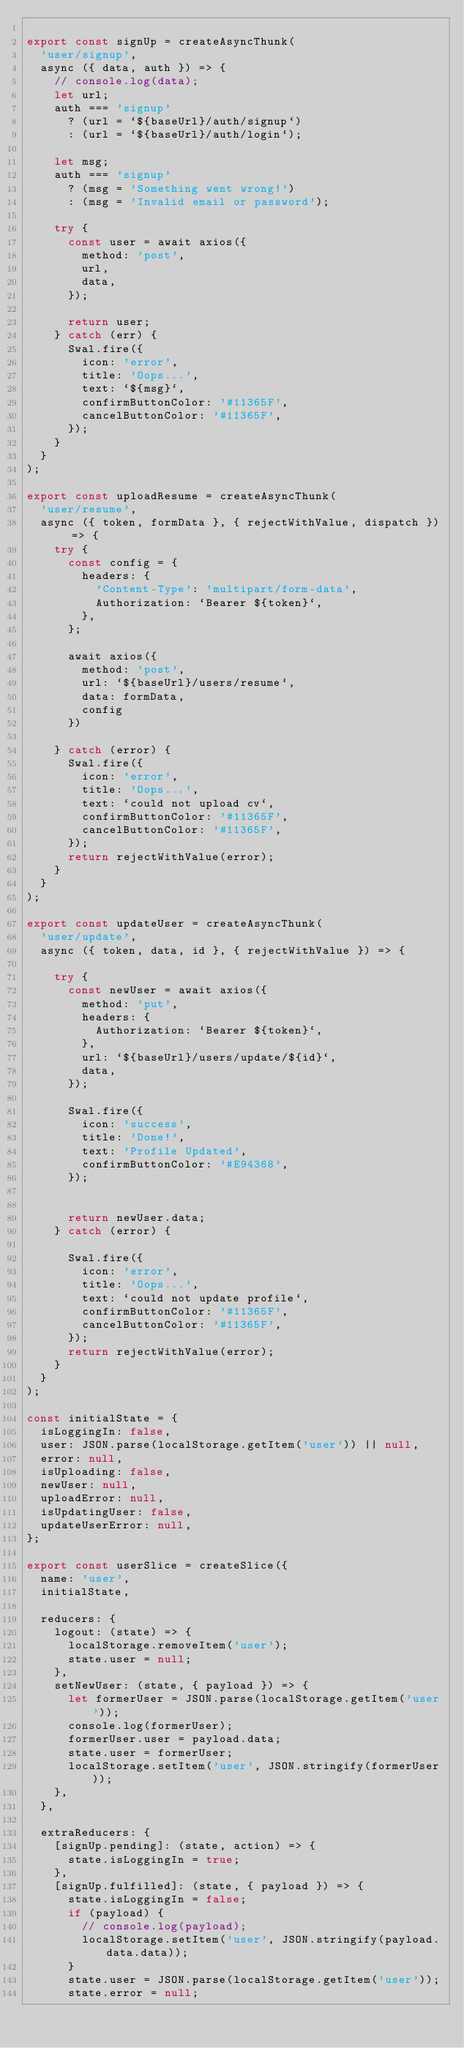<code> <loc_0><loc_0><loc_500><loc_500><_JavaScript_>
export const signUp = createAsyncThunk(
  'user/signup',
  async ({ data, auth }) => {
    // console.log(data);
    let url;
    auth === 'signup'
      ? (url = `${baseUrl}/auth/signup`)
      : (url = `${baseUrl}/auth/login`);

    let msg;
    auth === 'signup'
      ? (msg = 'Something went wrong!')
      : (msg = 'Invalid email or password');

    try {
      const user = await axios({
        method: 'post',
        url,
        data,
      });

      return user;
    } catch (err) {
      Swal.fire({
        icon: 'error',
        title: 'Oops...',
        text: `${msg}`,
        confirmButtonColor: '#11365F',
        cancelButtonColor: '#11365F',
      });
    }
  }
);

export const uploadResume = createAsyncThunk(
  'user/resume',
  async ({ token, formData }, { rejectWithValue, dispatch }) => {
    try {
      const config = {
        headers: {
          'Content-Type': 'multipart/form-data',
          Authorization: `Bearer ${token}`,
        },
      };

      await axios({
        method: 'post',
        url: `${baseUrl}/users/resume`,
        data: formData,
        config
      })

    } catch (error) {
      Swal.fire({
        icon: 'error',
        title: 'Oops...',
        text: `could not upload cv`,
        confirmButtonColor: '#11365F',
        cancelButtonColor: '#11365F',
      });
      return rejectWithValue(error);
    }
  }
);

export const updateUser = createAsyncThunk(
  'user/update',
  async ({ token, data, id }, { rejectWithValue }) => {

    try {
      const newUser = await axios({
        method: 'put',
        headers: {
          Authorization: `Bearer ${token}`,
        },
        url: `${baseUrl}/users/update/${id}`,
        data,
      });

      Swal.fire({
        icon: 'success',
        title: 'Done!',
        text: 'Profile Updated',
        confirmButtonColor: '#E94368',
      });


      return newUser.data;
    } catch (error) {

      Swal.fire({
        icon: 'error',
        title: 'Oops...',
        text: `could not update profile`,
        confirmButtonColor: '#11365F',
        cancelButtonColor: '#11365F',
      });
      return rejectWithValue(error);
    }
  }
);

const initialState = {
  isLoggingIn: false,
  user: JSON.parse(localStorage.getItem('user')) || null,
  error: null,
  isUploading: false,
  newUser: null,
  uploadError: null,
  isUpdatingUser: false,
  updateUserError: null,
};

export const userSlice = createSlice({
  name: 'user',
  initialState,

  reducers: {
    logout: (state) => {
      localStorage.removeItem('user');
      state.user = null;
    },
    setNewUser: (state, { payload }) => {
      let formerUser = JSON.parse(localStorage.getItem('user'));
      console.log(formerUser);
      formerUser.user = payload.data;
      state.user = formerUser;
      localStorage.setItem('user', JSON.stringify(formerUser));
    },
  },

  extraReducers: {
    [signUp.pending]: (state, action) => {
      state.isLoggingIn = true;
    },
    [signUp.fulfilled]: (state, { payload }) => {
      state.isLoggingIn = false;
      if (payload) {
        // console.log(payload);
        localStorage.setItem('user', JSON.stringify(payload.data.data));
      }
      state.user = JSON.parse(localStorage.getItem('user'));
      state.error = null;</code> 